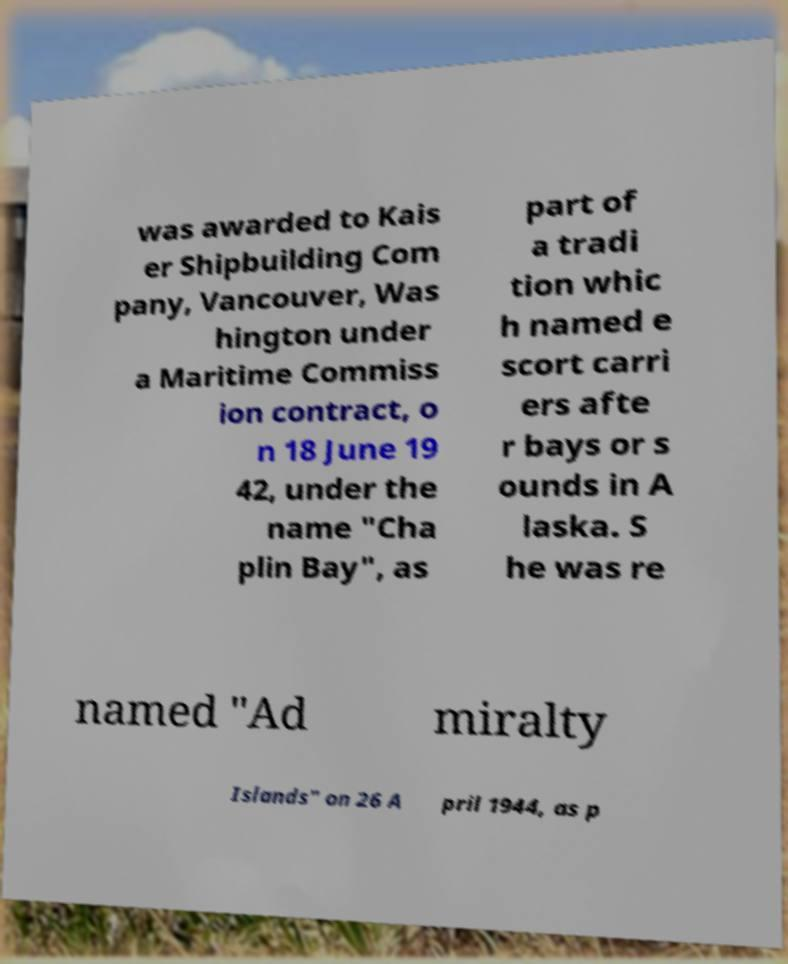I need the written content from this picture converted into text. Can you do that? was awarded to Kais er Shipbuilding Com pany, Vancouver, Was hington under a Maritime Commiss ion contract, o n 18 June 19 42, under the name "Cha plin Bay", as part of a tradi tion whic h named e scort carri ers afte r bays or s ounds in A laska. S he was re named "Ad miralty Islands" on 26 A pril 1944, as p 